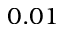<formula> <loc_0><loc_0><loc_500><loc_500>0 . 0 1</formula> 